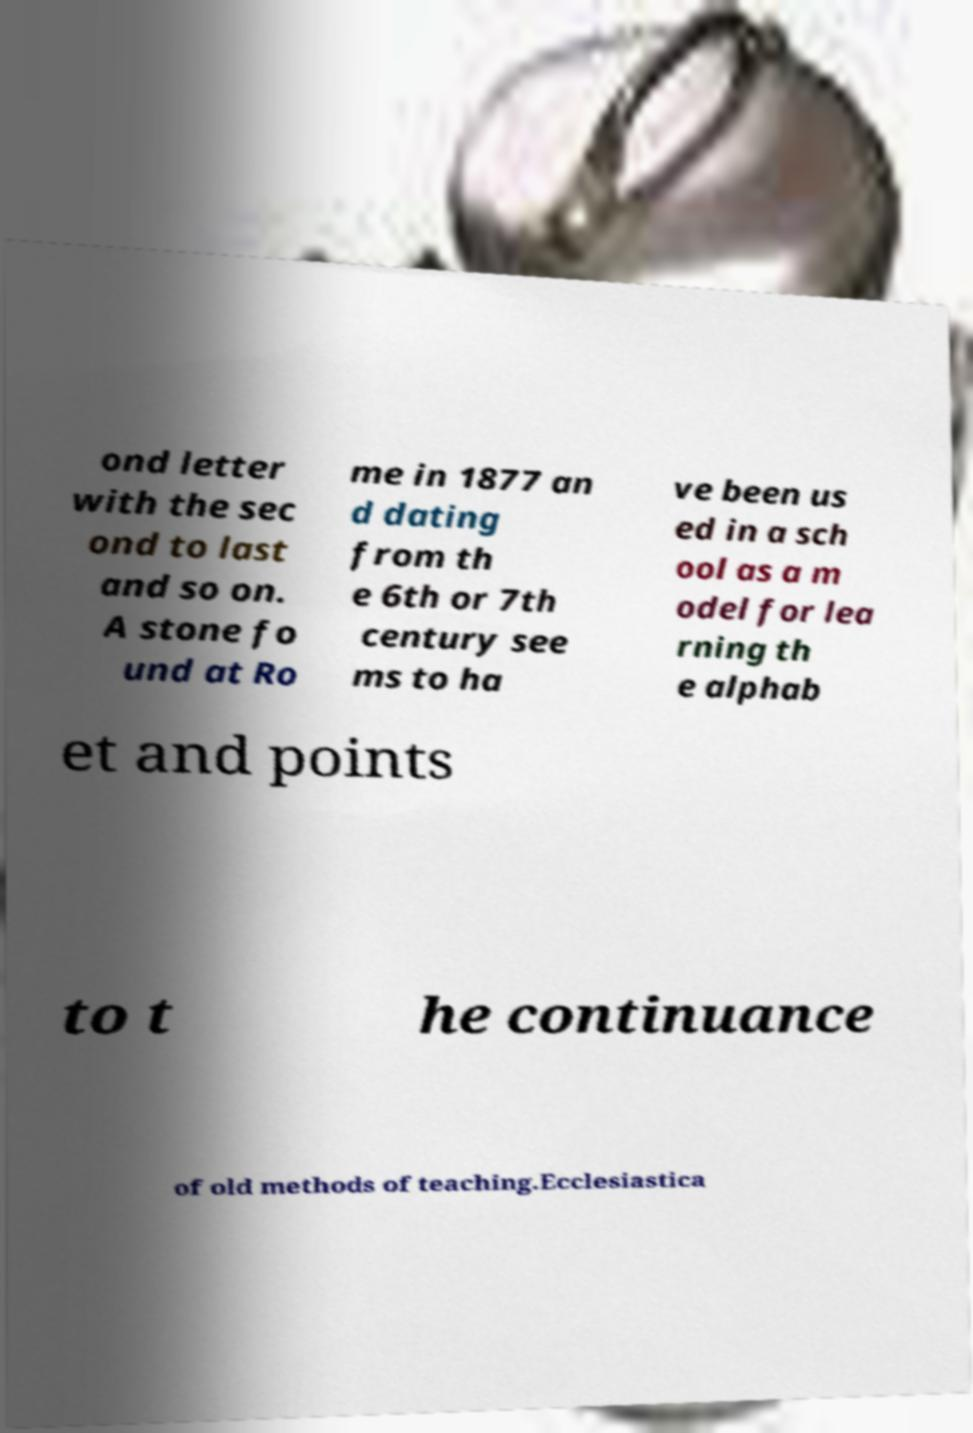I need the written content from this picture converted into text. Can you do that? ond letter with the sec ond to last and so on. A stone fo und at Ro me in 1877 an d dating from th e 6th or 7th century see ms to ha ve been us ed in a sch ool as a m odel for lea rning th e alphab et and points to t he continuance of old methods of teaching.Ecclesiastica 